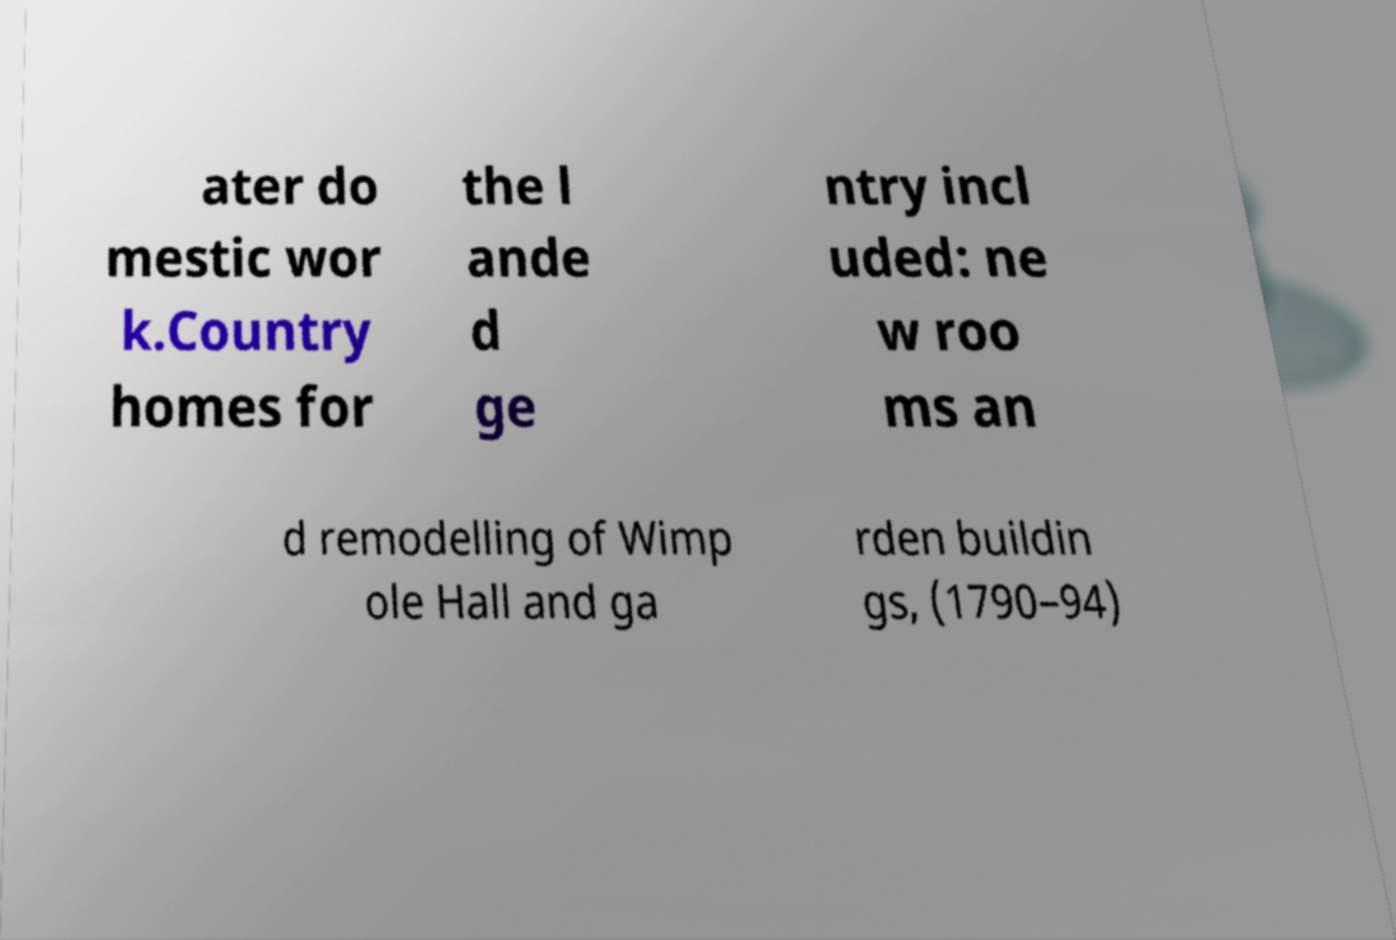There's text embedded in this image that I need extracted. Can you transcribe it verbatim? ater do mestic wor k.Country homes for the l ande d ge ntry incl uded: ne w roo ms an d remodelling of Wimp ole Hall and ga rden buildin gs, (1790–94) 